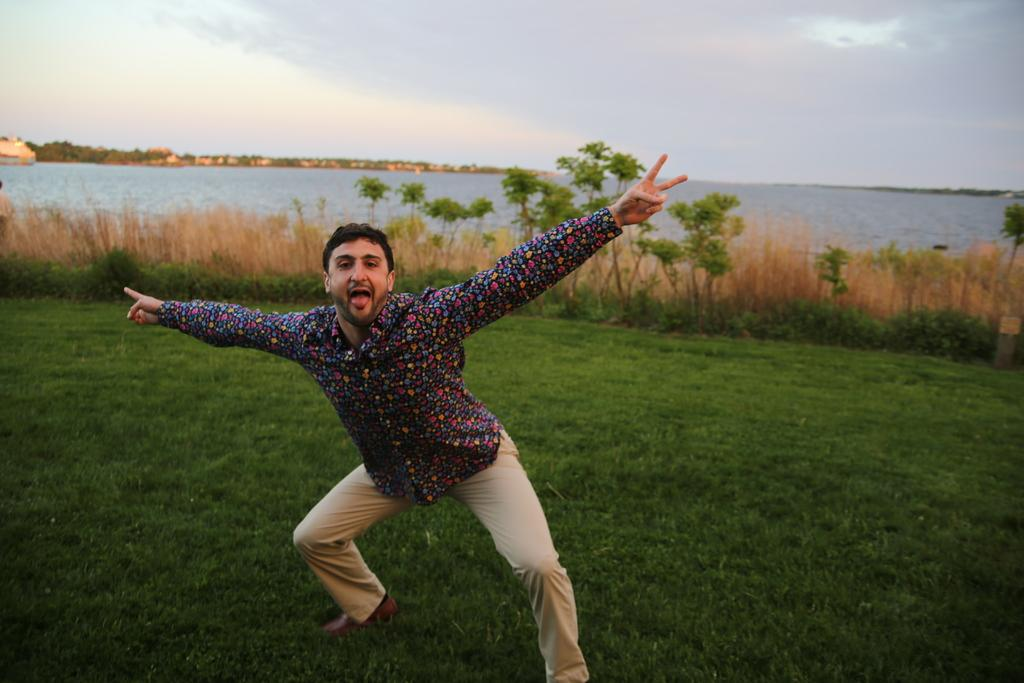What is the main subject of the image? There is a man standing in the image. Where is the man standing? The man is standing on grass. What type of vegetation can be seen in the image? There are plants and trees in the image. What natural features are visible in the background? There is an ocean and mountains in the image. What is the condition of the sky in the image? The sky is clear in the image. What type of toys can be seen in the hands of the queen in the image? There is no queen or toys present in the image. What type of lumber is being used to construct the mountains in the image? The mountains in the image are natural formations and not constructed with lumber. 